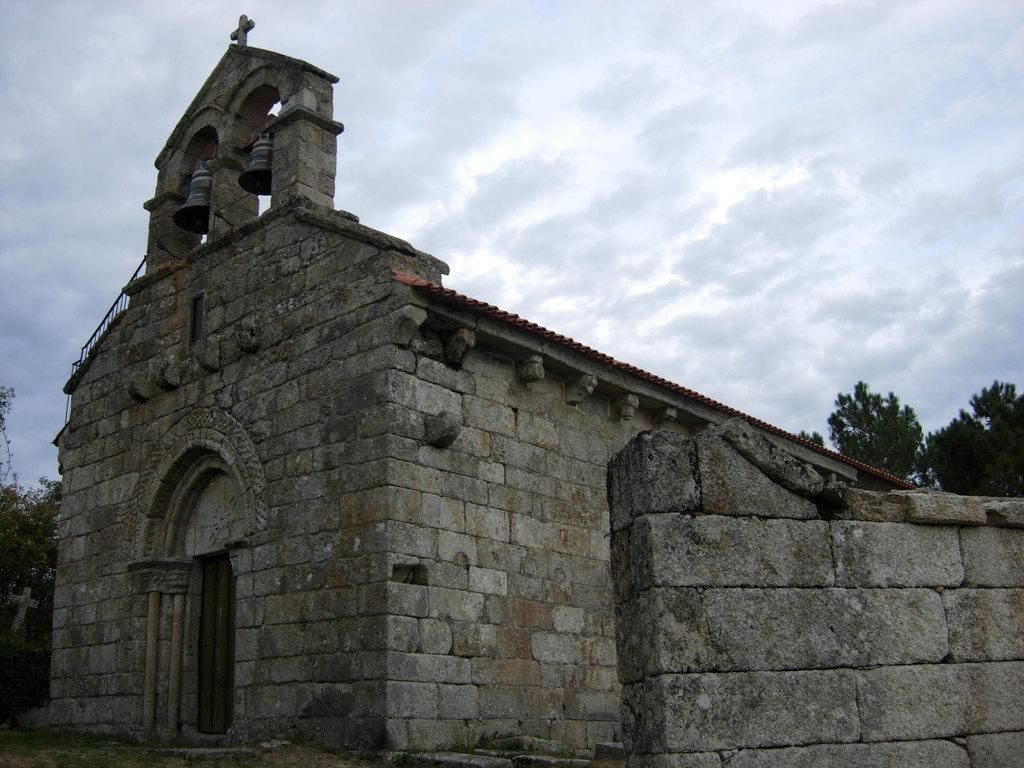What type of structure is visible in the image? There is a house in the image. What other natural elements can be seen in the image? There are trees in the image. What is visible at the top of the image? The sky is visible at the top of the image. What can be observed in the sky? Clouds are present in the sky. What type of fruit is being requested by the kittens in the image? There are no kittens or fruit present in the image. 